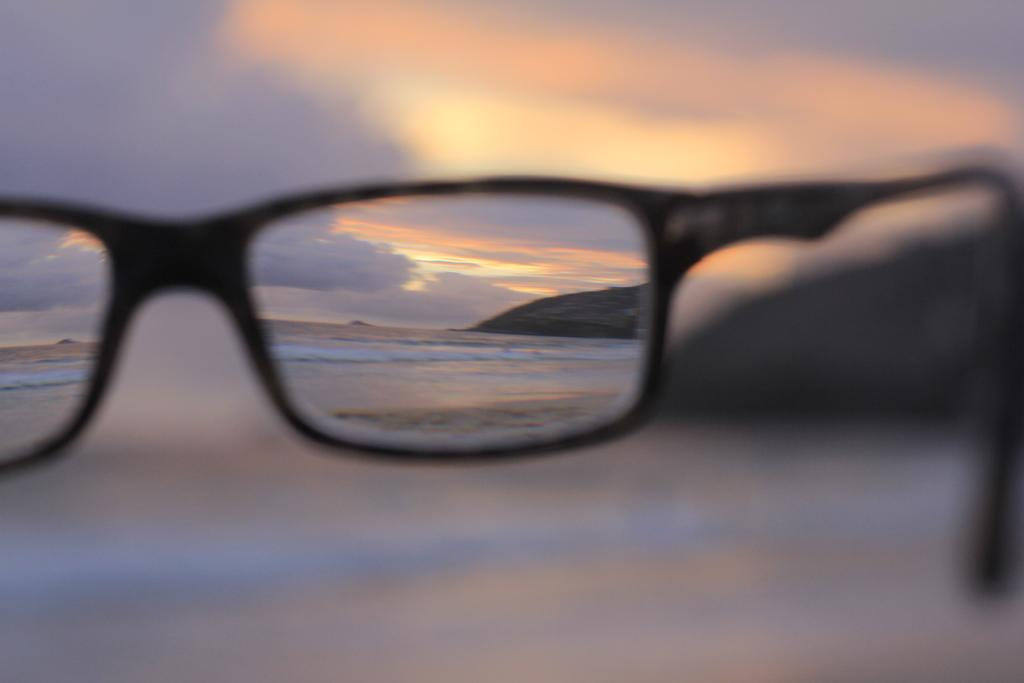What object is present in the image that can provide a view? There are spectacles in the image that can provide a view. What is the color of the spectacles? The spectacles are black in color. What can be seen through the spectacles in the image? Water, a mountain, and the sky can be seen through the spectacles in the image. How does the background appear in the image? The background appears blurry. What type of fowl can be seen teaching in the image? There is no fowl or teaching activity present in the image. What degree of education does the person wearing the spectacles have in the image? There is no information about the person's education level in the image. 